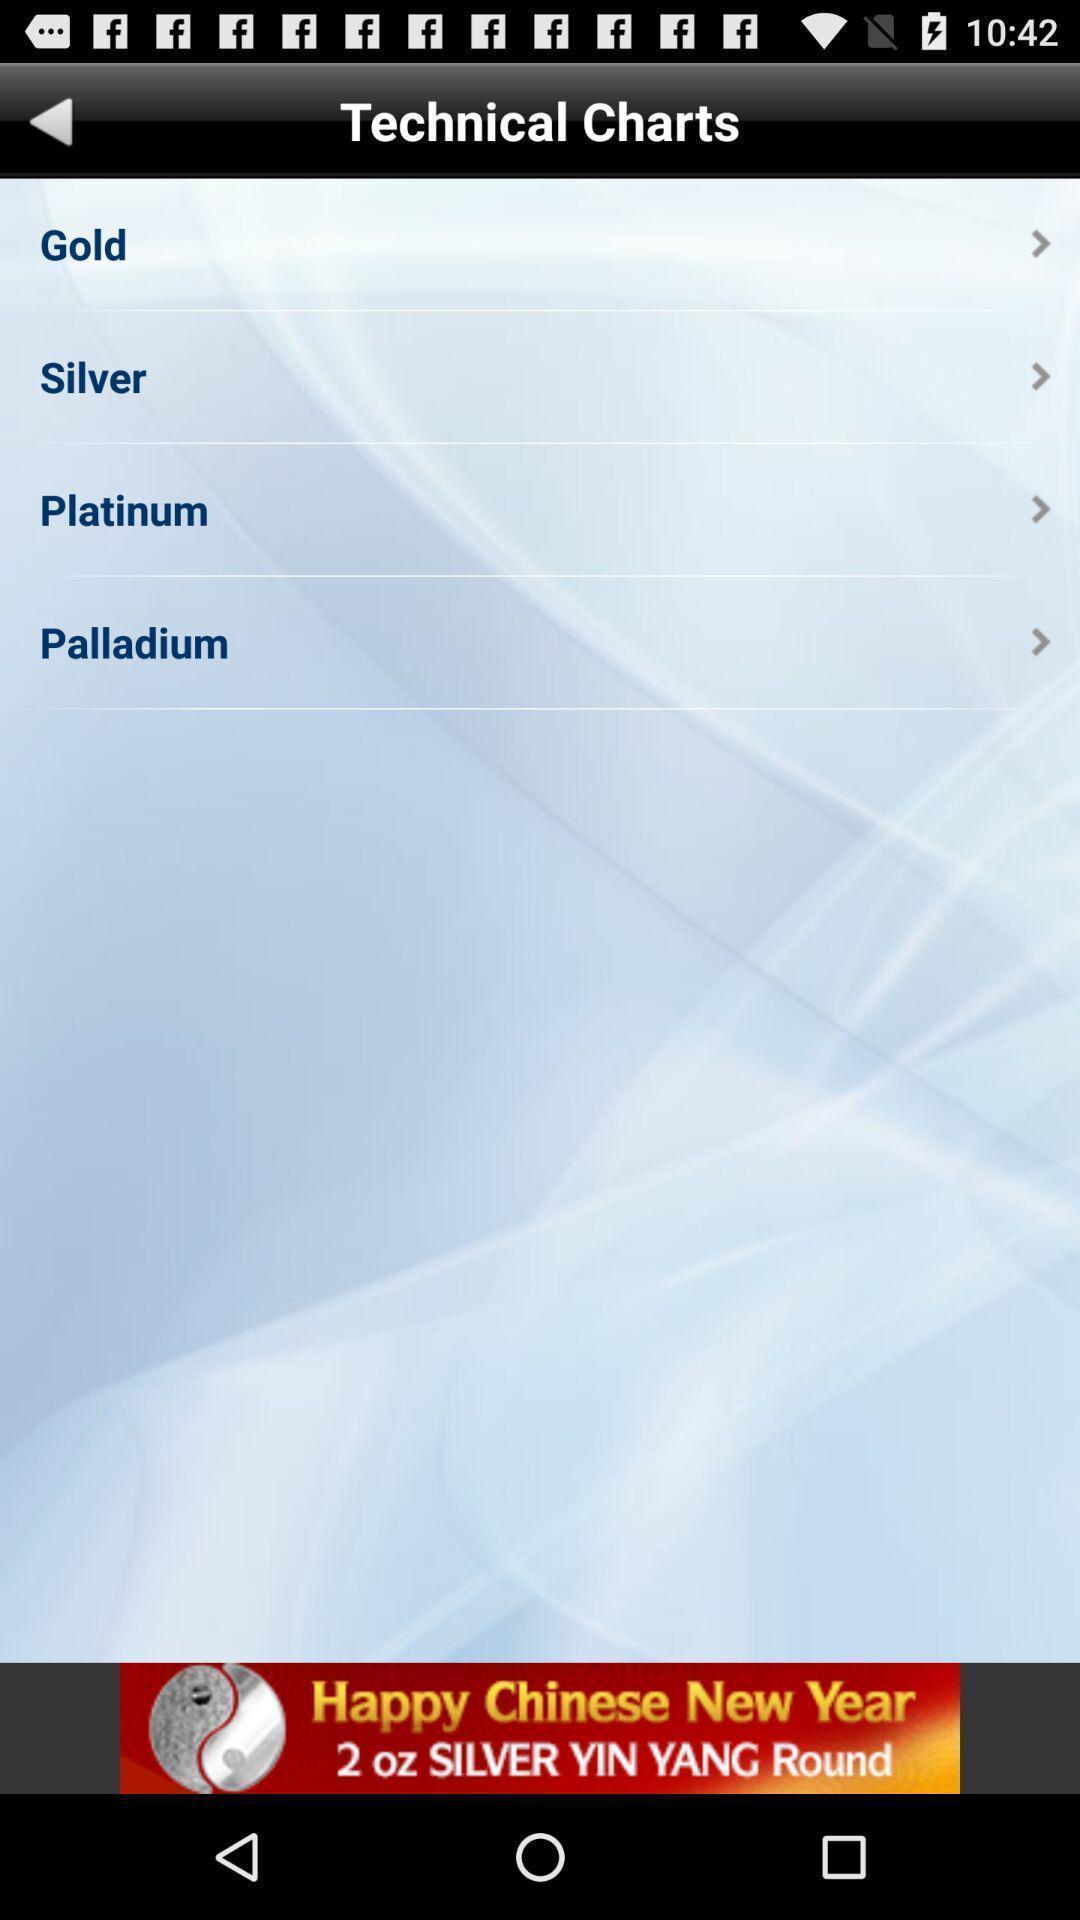Describe the content in this image. Screen shows list of technical charts. 